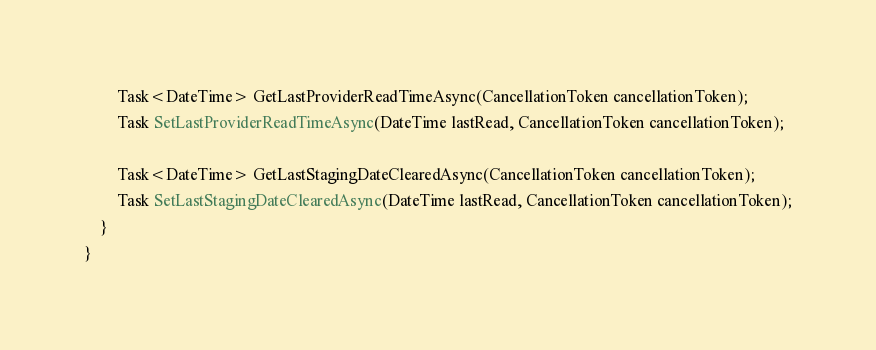<code> <loc_0><loc_0><loc_500><loc_500><_C#_>        Task<DateTime> GetLastProviderReadTimeAsync(CancellationToken cancellationToken);
        Task SetLastProviderReadTimeAsync(DateTime lastRead, CancellationToken cancellationToken);
        
        Task<DateTime> GetLastStagingDateClearedAsync(CancellationToken cancellationToken);
        Task SetLastStagingDateClearedAsync(DateTime lastRead, CancellationToken cancellationToken);
    }
}</code> 